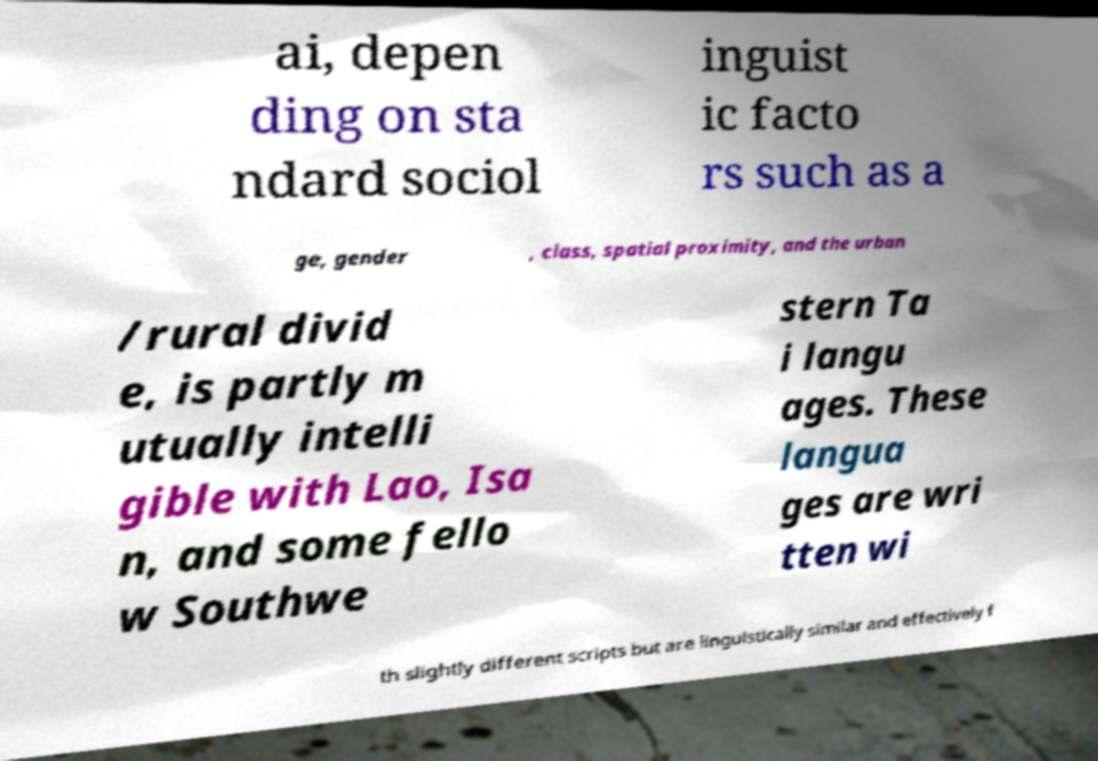What messages or text are displayed in this image? I need them in a readable, typed format. ai, depen ding on sta ndard sociol inguist ic facto rs such as a ge, gender , class, spatial proximity, and the urban /rural divid e, is partly m utually intelli gible with Lao, Isa n, and some fello w Southwe stern Ta i langu ages. These langua ges are wri tten wi th slightly different scripts but are linguistically similar and effectively f 